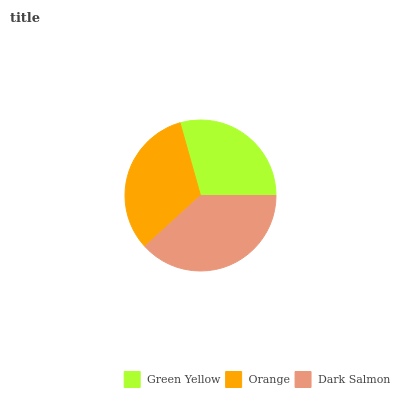Is Green Yellow the minimum?
Answer yes or no. Yes. Is Dark Salmon the maximum?
Answer yes or no. Yes. Is Orange the minimum?
Answer yes or no. No. Is Orange the maximum?
Answer yes or no. No. Is Orange greater than Green Yellow?
Answer yes or no. Yes. Is Green Yellow less than Orange?
Answer yes or no. Yes. Is Green Yellow greater than Orange?
Answer yes or no. No. Is Orange less than Green Yellow?
Answer yes or no. No. Is Orange the high median?
Answer yes or no. Yes. Is Orange the low median?
Answer yes or no. Yes. Is Dark Salmon the high median?
Answer yes or no. No. Is Dark Salmon the low median?
Answer yes or no. No. 